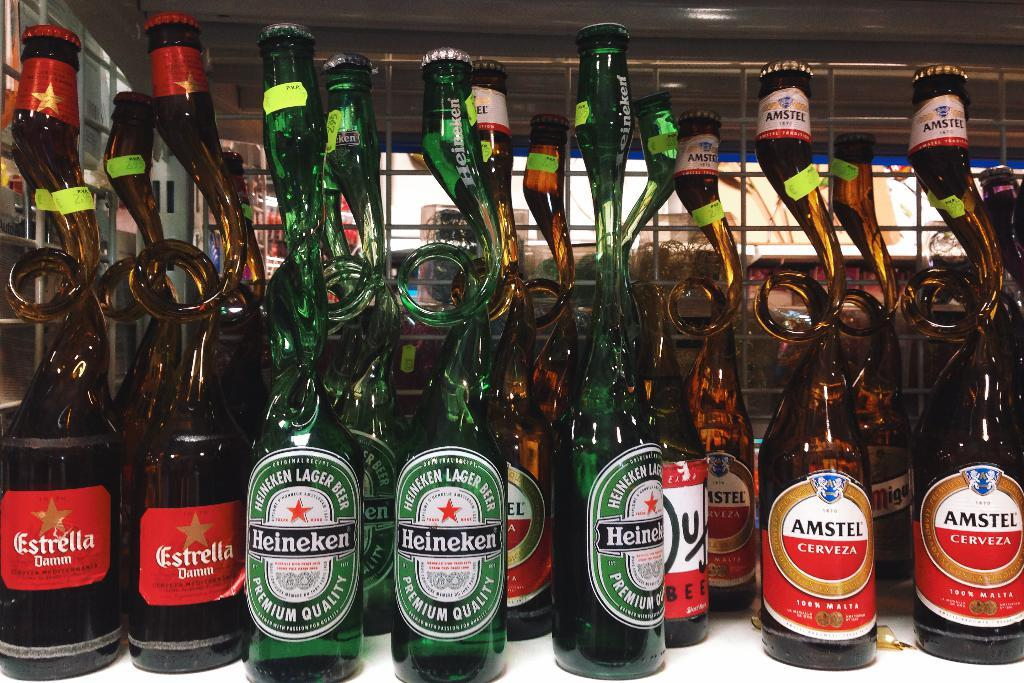Provide a one-sentence caption for the provided image. a unusual bottle shape collection of Estrella, Heinekin and Amstel liquor. 